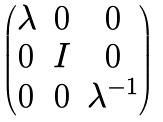<formula> <loc_0><loc_0><loc_500><loc_500>\begin{pmatrix} \lambda & 0 & 0 \\ 0 & I & 0 \\ 0 & 0 & \lambda ^ { - 1 } \end{pmatrix}</formula> 